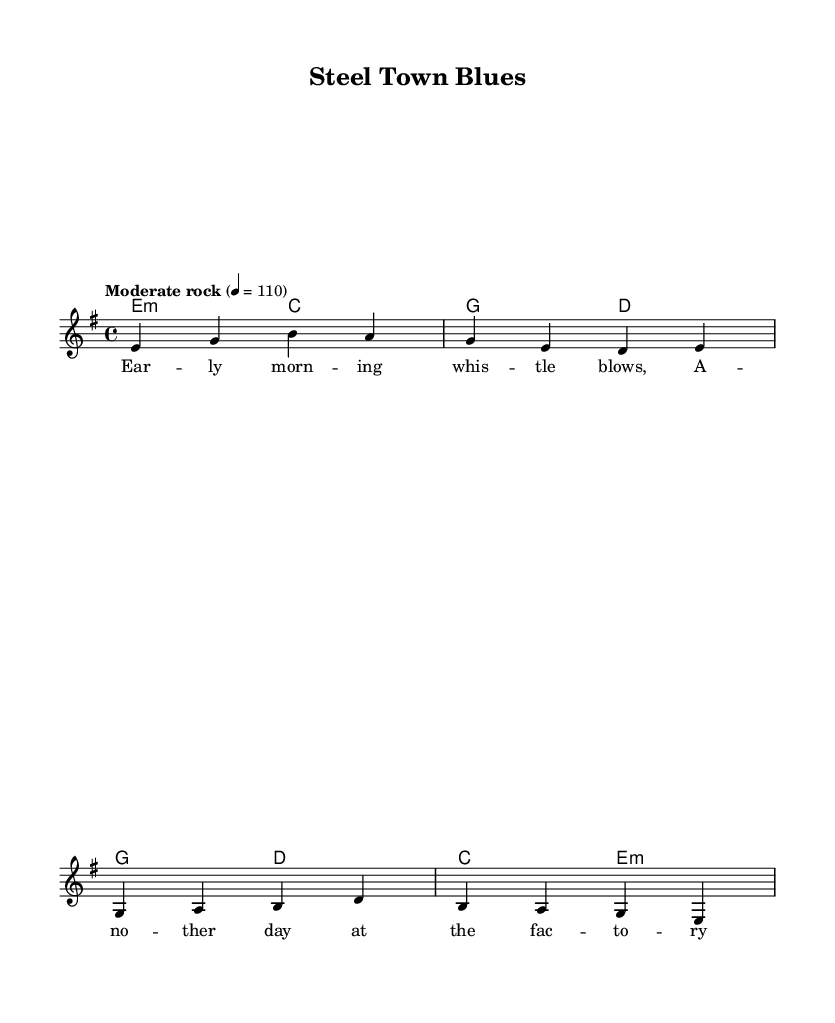What is the key signature of this music? The key signature is E minor, which is indicated in the global section of the code and consists of one sharp (F#).
Answer: E minor What is the time signature of the piece? The time signature is 4/4, which is also stated in the global section of the code. This means there are four beats in each measure and the quarter note gets one beat.
Answer: 4/4 What is the tempo marking for the music? The tempo marking is "Moderate rock," with an indication of 4 = 110, meaning the quarter note is played at a speed of 110 beats per minute.
Answer: Moderate rock What is the structure of the song? The structure consists of a verse followed by a chorus, as indicated in the lyrical sections labeled "verse" and "chorus." The score format reflects this order, making it a verse-chorus format which is common in rock music.
Answer: Verse-Chorus Which elements of rock music are identified in the lyrics? The lyrics emphasize themes of working-class life and resilience, which are common in classic rock songs. The line "We're the backbone of this nation" highlights pride in labor, a significant aspect of the working-class narrative in classic rock.
Answer: Working-class experience What is the relative pitch relationship in the melody? The melody starts lower (E) and goes higher (G, B) before coming back down, creating a contour that moves around the tonic note (E), which is typical in melodic construction in rock music, allowing for expressive dynamics and themes.
Answer: Ascending and descending pitches 